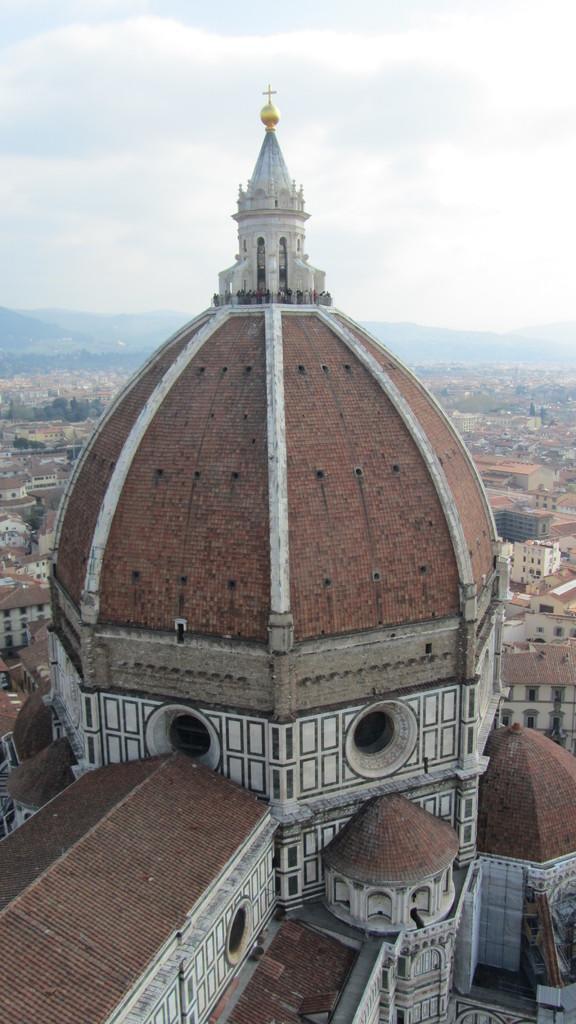How would you summarize this image in a sentence or two? In this image I can see a building in the front. There are buildings and mountains at the back. There is sky at the top. 